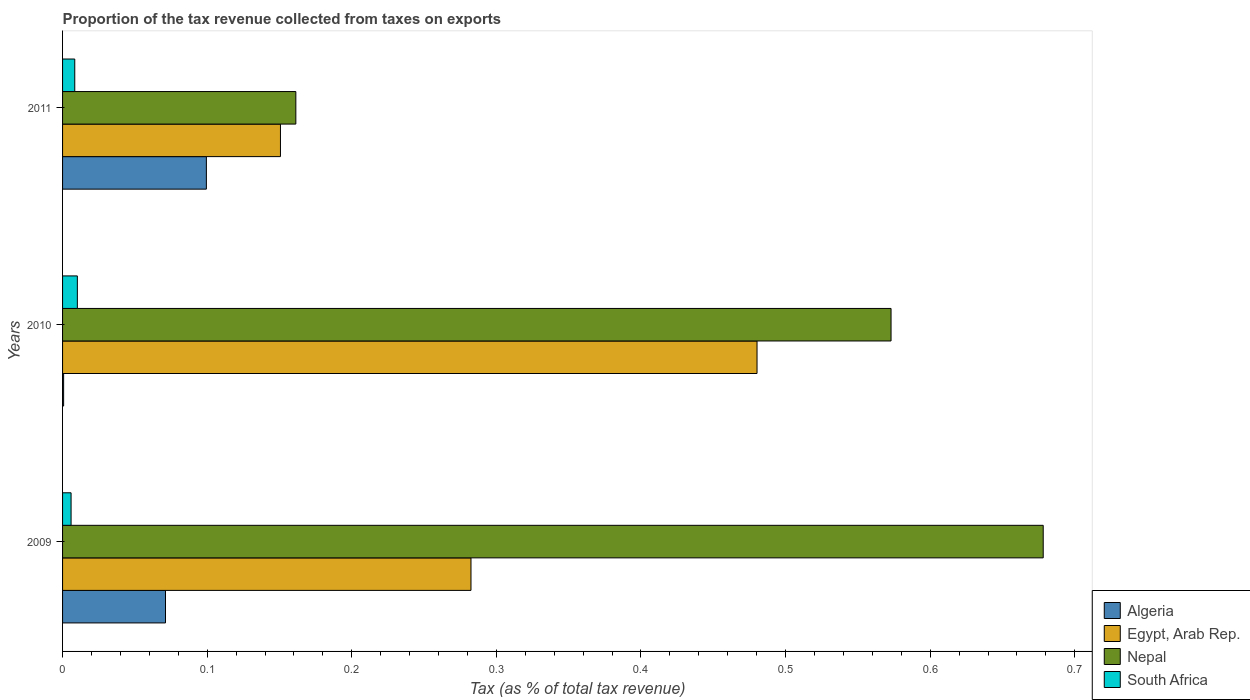How many different coloured bars are there?
Give a very brief answer. 4. How many bars are there on the 3rd tick from the top?
Your response must be concise. 4. How many bars are there on the 3rd tick from the bottom?
Your answer should be very brief. 4. What is the label of the 2nd group of bars from the top?
Your response must be concise. 2010. What is the proportion of the tax revenue collected in South Africa in 2010?
Give a very brief answer. 0.01. Across all years, what is the maximum proportion of the tax revenue collected in Nepal?
Offer a terse response. 0.68. Across all years, what is the minimum proportion of the tax revenue collected in Egypt, Arab Rep.?
Offer a very short reply. 0.15. In which year was the proportion of the tax revenue collected in Nepal maximum?
Give a very brief answer. 2009. What is the total proportion of the tax revenue collected in Algeria in the graph?
Your response must be concise. 0.17. What is the difference between the proportion of the tax revenue collected in Algeria in 2009 and that in 2011?
Provide a succinct answer. -0.03. What is the difference between the proportion of the tax revenue collected in Nepal in 2009 and the proportion of the tax revenue collected in Algeria in 2011?
Make the answer very short. 0.58. What is the average proportion of the tax revenue collected in South Africa per year?
Keep it short and to the point. 0.01. In the year 2010, what is the difference between the proportion of the tax revenue collected in South Africa and proportion of the tax revenue collected in Algeria?
Your answer should be compact. 0.01. What is the ratio of the proportion of the tax revenue collected in South Africa in 2009 to that in 2010?
Provide a short and direct response. 0.58. Is the proportion of the tax revenue collected in Algeria in 2009 less than that in 2010?
Provide a short and direct response. No. What is the difference between the highest and the second highest proportion of the tax revenue collected in Algeria?
Provide a succinct answer. 0.03. What is the difference between the highest and the lowest proportion of the tax revenue collected in Nepal?
Your answer should be compact. 0.52. In how many years, is the proportion of the tax revenue collected in South Africa greater than the average proportion of the tax revenue collected in South Africa taken over all years?
Provide a succinct answer. 2. Is it the case that in every year, the sum of the proportion of the tax revenue collected in Algeria and proportion of the tax revenue collected in Egypt, Arab Rep. is greater than the sum of proportion of the tax revenue collected in Nepal and proportion of the tax revenue collected in South Africa?
Offer a very short reply. Yes. What does the 4th bar from the top in 2011 represents?
Provide a succinct answer. Algeria. What does the 4th bar from the bottom in 2010 represents?
Provide a succinct answer. South Africa. How many bars are there?
Offer a very short reply. 12. Are all the bars in the graph horizontal?
Offer a terse response. Yes. How many years are there in the graph?
Provide a succinct answer. 3. What is the difference between two consecutive major ticks on the X-axis?
Keep it short and to the point. 0.1. Are the values on the major ticks of X-axis written in scientific E-notation?
Offer a terse response. No. Where does the legend appear in the graph?
Offer a terse response. Bottom right. How many legend labels are there?
Keep it short and to the point. 4. How are the legend labels stacked?
Ensure brevity in your answer.  Vertical. What is the title of the graph?
Make the answer very short. Proportion of the tax revenue collected from taxes on exports. Does "World" appear as one of the legend labels in the graph?
Give a very brief answer. No. What is the label or title of the X-axis?
Give a very brief answer. Tax (as % of total tax revenue). What is the Tax (as % of total tax revenue) of Algeria in 2009?
Your response must be concise. 0.07. What is the Tax (as % of total tax revenue) of Egypt, Arab Rep. in 2009?
Provide a short and direct response. 0.28. What is the Tax (as % of total tax revenue) of Nepal in 2009?
Give a very brief answer. 0.68. What is the Tax (as % of total tax revenue) of South Africa in 2009?
Offer a very short reply. 0.01. What is the Tax (as % of total tax revenue) in Algeria in 2010?
Keep it short and to the point. 0. What is the Tax (as % of total tax revenue) of Egypt, Arab Rep. in 2010?
Give a very brief answer. 0.48. What is the Tax (as % of total tax revenue) in Nepal in 2010?
Offer a terse response. 0.57. What is the Tax (as % of total tax revenue) in South Africa in 2010?
Your answer should be very brief. 0.01. What is the Tax (as % of total tax revenue) of Algeria in 2011?
Keep it short and to the point. 0.1. What is the Tax (as % of total tax revenue) of Egypt, Arab Rep. in 2011?
Offer a very short reply. 0.15. What is the Tax (as % of total tax revenue) of Nepal in 2011?
Ensure brevity in your answer.  0.16. What is the Tax (as % of total tax revenue) of South Africa in 2011?
Provide a short and direct response. 0.01. Across all years, what is the maximum Tax (as % of total tax revenue) in Algeria?
Offer a terse response. 0.1. Across all years, what is the maximum Tax (as % of total tax revenue) in Egypt, Arab Rep.?
Provide a short and direct response. 0.48. Across all years, what is the maximum Tax (as % of total tax revenue) in Nepal?
Make the answer very short. 0.68. Across all years, what is the maximum Tax (as % of total tax revenue) of South Africa?
Your answer should be very brief. 0.01. Across all years, what is the minimum Tax (as % of total tax revenue) in Algeria?
Keep it short and to the point. 0. Across all years, what is the minimum Tax (as % of total tax revenue) in Egypt, Arab Rep.?
Provide a short and direct response. 0.15. Across all years, what is the minimum Tax (as % of total tax revenue) in Nepal?
Make the answer very short. 0.16. Across all years, what is the minimum Tax (as % of total tax revenue) in South Africa?
Offer a very short reply. 0.01. What is the total Tax (as % of total tax revenue) of Algeria in the graph?
Keep it short and to the point. 0.17. What is the total Tax (as % of total tax revenue) in Egypt, Arab Rep. in the graph?
Provide a succinct answer. 0.91. What is the total Tax (as % of total tax revenue) of Nepal in the graph?
Make the answer very short. 1.41. What is the total Tax (as % of total tax revenue) of South Africa in the graph?
Provide a short and direct response. 0.02. What is the difference between the Tax (as % of total tax revenue) of Algeria in 2009 and that in 2010?
Offer a terse response. 0.07. What is the difference between the Tax (as % of total tax revenue) in Egypt, Arab Rep. in 2009 and that in 2010?
Provide a short and direct response. -0.2. What is the difference between the Tax (as % of total tax revenue) in Nepal in 2009 and that in 2010?
Make the answer very short. 0.11. What is the difference between the Tax (as % of total tax revenue) in South Africa in 2009 and that in 2010?
Your response must be concise. -0. What is the difference between the Tax (as % of total tax revenue) in Algeria in 2009 and that in 2011?
Provide a succinct answer. -0.03. What is the difference between the Tax (as % of total tax revenue) in Egypt, Arab Rep. in 2009 and that in 2011?
Keep it short and to the point. 0.13. What is the difference between the Tax (as % of total tax revenue) of Nepal in 2009 and that in 2011?
Offer a terse response. 0.52. What is the difference between the Tax (as % of total tax revenue) in South Africa in 2009 and that in 2011?
Your response must be concise. -0. What is the difference between the Tax (as % of total tax revenue) in Algeria in 2010 and that in 2011?
Offer a terse response. -0.1. What is the difference between the Tax (as % of total tax revenue) of Egypt, Arab Rep. in 2010 and that in 2011?
Make the answer very short. 0.33. What is the difference between the Tax (as % of total tax revenue) of Nepal in 2010 and that in 2011?
Keep it short and to the point. 0.41. What is the difference between the Tax (as % of total tax revenue) in South Africa in 2010 and that in 2011?
Offer a terse response. 0. What is the difference between the Tax (as % of total tax revenue) in Algeria in 2009 and the Tax (as % of total tax revenue) in Egypt, Arab Rep. in 2010?
Provide a short and direct response. -0.41. What is the difference between the Tax (as % of total tax revenue) of Algeria in 2009 and the Tax (as % of total tax revenue) of Nepal in 2010?
Your answer should be very brief. -0.5. What is the difference between the Tax (as % of total tax revenue) in Algeria in 2009 and the Tax (as % of total tax revenue) in South Africa in 2010?
Provide a succinct answer. 0.06. What is the difference between the Tax (as % of total tax revenue) of Egypt, Arab Rep. in 2009 and the Tax (as % of total tax revenue) of Nepal in 2010?
Your answer should be very brief. -0.29. What is the difference between the Tax (as % of total tax revenue) of Egypt, Arab Rep. in 2009 and the Tax (as % of total tax revenue) of South Africa in 2010?
Keep it short and to the point. 0.27. What is the difference between the Tax (as % of total tax revenue) in Nepal in 2009 and the Tax (as % of total tax revenue) in South Africa in 2010?
Offer a very short reply. 0.67. What is the difference between the Tax (as % of total tax revenue) of Algeria in 2009 and the Tax (as % of total tax revenue) of Egypt, Arab Rep. in 2011?
Your answer should be compact. -0.08. What is the difference between the Tax (as % of total tax revenue) of Algeria in 2009 and the Tax (as % of total tax revenue) of Nepal in 2011?
Keep it short and to the point. -0.09. What is the difference between the Tax (as % of total tax revenue) in Algeria in 2009 and the Tax (as % of total tax revenue) in South Africa in 2011?
Your response must be concise. 0.06. What is the difference between the Tax (as % of total tax revenue) in Egypt, Arab Rep. in 2009 and the Tax (as % of total tax revenue) in Nepal in 2011?
Your response must be concise. 0.12. What is the difference between the Tax (as % of total tax revenue) in Egypt, Arab Rep. in 2009 and the Tax (as % of total tax revenue) in South Africa in 2011?
Offer a terse response. 0.27. What is the difference between the Tax (as % of total tax revenue) of Nepal in 2009 and the Tax (as % of total tax revenue) of South Africa in 2011?
Make the answer very short. 0.67. What is the difference between the Tax (as % of total tax revenue) in Algeria in 2010 and the Tax (as % of total tax revenue) in Egypt, Arab Rep. in 2011?
Provide a succinct answer. -0.15. What is the difference between the Tax (as % of total tax revenue) of Algeria in 2010 and the Tax (as % of total tax revenue) of Nepal in 2011?
Provide a succinct answer. -0.16. What is the difference between the Tax (as % of total tax revenue) of Algeria in 2010 and the Tax (as % of total tax revenue) of South Africa in 2011?
Give a very brief answer. -0.01. What is the difference between the Tax (as % of total tax revenue) of Egypt, Arab Rep. in 2010 and the Tax (as % of total tax revenue) of Nepal in 2011?
Your response must be concise. 0.32. What is the difference between the Tax (as % of total tax revenue) of Egypt, Arab Rep. in 2010 and the Tax (as % of total tax revenue) of South Africa in 2011?
Ensure brevity in your answer.  0.47. What is the difference between the Tax (as % of total tax revenue) of Nepal in 2010 and the Tax (as % of total tax revenue) of South Africa in 2011?
Make the answer very short. 0.56. What is the average Tax (as % of total tax revenue) of Algeria per year?
Offer a terse response. 0.06. What is the average Tax (as % of total tax revenue) of Egypt, Arab Rep. per year?
Your answer should be compact. 0.3. What is the average Tax (as % of total tax revenue) in Nepal per year?
Your answer should be very brief. 0.47. What is the average Tax (as % of total tax revenue) in South Africa per year?
Offer a terse response. 0.01. In the year 2009, what is the difference between the Tax (as % of total tax revenue) of Algeria and Tax (as % of total tax revenue) of Egypt, Arab Rep.?
Give a very brief answer. -0.21. In the year 2009, what is the difference between the Tax (as % of total tax revenue) in Algeria and Tax (as % of total tax revenue) in Nepal?
Your answer should be compact. -0.61. In the year 2009, what is the difference between the Tax (as % of total tax revenue) of Algeria and Tax (as % of total tax revenue) of South Africa?
Your response must be concise. 0.07. In the year 2009, what is the difference between the Tax (as % of total tax revenue) of Egypt, Arab Rep. and Tax (as % of total tax revenue) of Nepal?
Provide a succinct answer. -0.4. In the year 2009, what is the difference between the Tax (as % of total tax revenue) of Egypt, Arab Rep. and Tax (as % of total tax revenue) of South Africa?
Your answer should be very brief. 0.28. In the year 2009, what is the difference between the Tax (as % of total tax revenue) in Nepal and Tax (as % of total tax revenue) in South Africa?
Give a very brief answer. 0.67. In the year 2010, what is the difference between the Tax (as % of total tax revenue) in Algeria and Tax (as % of total tax revenue) in Egypt, Arab Rep.?
Provide a short and direct response. -0.48. In the year 2010, what is the difference between the Tax (as % of total tax revenue) in Algeria and Tax (as % of total tax revenue) in Nepal?
Keep it short and to the point. -0.57. In the year 2010, what is the difference between the Tax (as % of total tax revenue) of Algeria and Tax (as % of total tax revenue) of South Africa?
Offer a very short reply. -0.01. In the year 2010, what is the difference between the Tax (as % of total tax revenue) of Egypt, Arab Rep. and Tax (as % of total tax revenue) of Nepal?
Provide a succinct answer. -0.09. In the year 2010, what is the difference between the Tax (as % of total tax revenue) in Egypt, Arab Rep. and Tax (as % of total tax revenue) in South Africa?
Your answer should be very brief. 0.47. In the year 2010, what is the difference between the Tax (as % of total tax revenue) in Nepal and Tax (as % of total tax revenue) in South Africa?
Your answer should be compact. 0.56. In the year 2011, what is the difference between the Tax (as % of total tax revenue) in Algeria and Tax (as % of total tax revenue) in Egypt, Arab Rep.?
Your response must be concise. -0.05. In the year 2011, what is the difference between the Tax (as % of total tax revenue) of Algeria and Tax (as % of total tax revenue) of Nepal?
Give a very brief answer. -0.06. In the year 2011, what is the difference between the Tax (as % of total tax revenue) in Algeria and Tax (as % of total tax revenue) in South Africa?
Keep it short and to the point. 0.09. In the year 2011, what is the difference between the Tax (as % of total tax revenue) of Egypt, Arab Rep. and Tax (as % of total tax revenue) of Nepal?
Offer a terse response. -0.01. In the year 2011, what is the difference between the Tax (as % of total tax revenue) of Egypt, Arab Rep. and Tax (as % of total tax revenue) of South Africa?
Your answer should be compact. 0.14. In the year 2011, what is the difference between the Tax (as % of total tax revenue) of Nepal and Tax (as % of total tax revenue) of South Africa?
Keep it short and to the point. 0.15. What is the ratio of the Tax (as % of total tax revenue) of Algeria in 2009 to that in 2010?
Provide a short and direct response. 97.89. What is the ratio of the Tax (as % of total tax revenue) in Egypt, Arab Rep. in 2009 to that in 2010?
Your answer should be compact. 0.59. What is the ratio of the Tax (as % of total tax revenue) in Nepal in 2009 to that in 2010?
Give a very brief answer. 1.18. What is the ratio of the Tax (as % of total tax revenue) in South Africa in 2009 to that in 2010?
Your answer should be very brief. 0.58. What is the ratio of the Tax (as % of total tax revenue) in Algeria in 2009 to that in 2011?
Your answer should be compact. 0.72. What is the ratio of the Tax (as % of total tax revenue) in Egypt, Arab Rep. in 2009 to that in 2011?
Give a very brief answer. 1.87. What is the ratio of the Tax (as % of total tax revenue) in Nepal in 2009 to that in 2011?
Your answer should be very brief. 4.2. What is the ratio of the Tax (as % of total tax revenue) of South Africa in 2009 to that in 2011?
Ensure brevity in your answer.  0.7. What is the ratio of the Tax (as % of total tax revenue) in Algeria in 2010 to that in 2011?
Provide a short and direct response. 0.01. What is the ratio of the Tax (as % of total tax revenue) in Egypt, Arab Rep. in 2010 to that in 2011?
Ensure brevity in your answer.  3.19. What is the ratio of the Tax (as % of total tax revenue) in Nepal in 2010 to that in 2011?
Your answer should be compact. 3.55. What is the ratio of the Tax (as % of total tax revenue) of South Africa in 2010 to that in 2011?
Ensure brevity in your answer.  1.21. What is the difference between the highest and the second highest Tax (as % of total tax revenue) of Algeria?
Give a very brief answer. 0.03. What is the difference between the highest and the second highest Tax (as % of total tax revenue) of Egypt, Arab Rep.?
Your response must be concise. 0.2. What is the difference between the highest and the second highest Tax (as % of total tax revenue) of Nepal?
Make the answer very short. 0.11. What is the difference between the highest and the second highest Tax (as % of total tax revenue) in South Africa?
Ensure brevity in your answer.  0. What is the difference between the highest and the lowest Tax (as % of total tax revenue) of Algeria?
Offer a very short reply. 0.1. What is the difference between the highest and the lowest Tax (as % of total tax revenue) in Egypt, Arab Rep.?
Provide a short and direct response. 0.33. What is the difference between the highest and the lowest Tax (as % of total tax revenue) of Nepal?
Give a very brief answer. 0.52. What is the difference between the highest and the lowest Tax (as % of total tax revenue) of South Africa?
Provide a succinct answer. 0. 